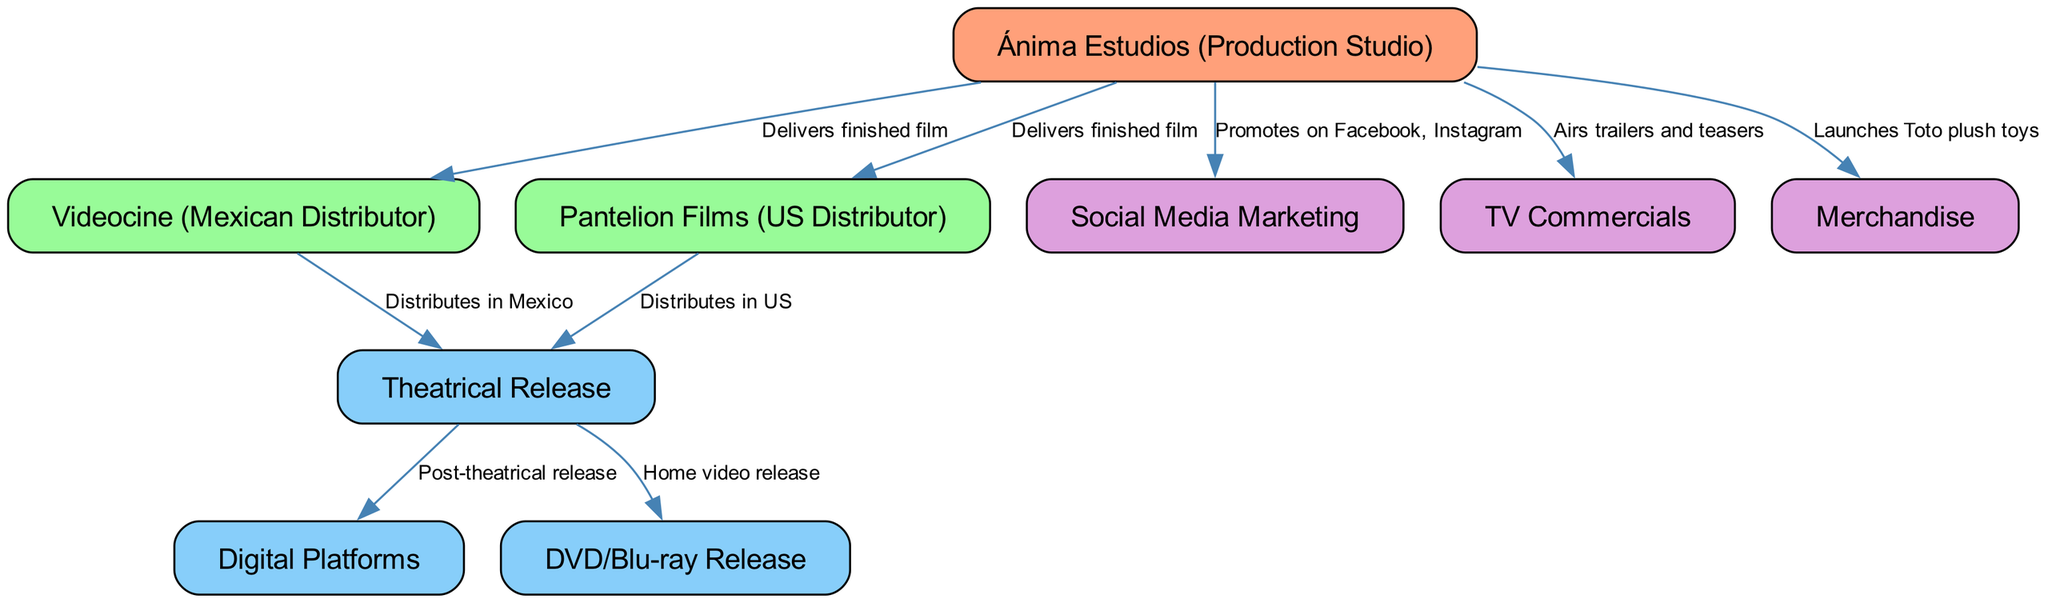What is the primary production studio for the "Huevos" series? The diagram shows that "Ánima Estudios" is the production studio responsible for creating the films, as it is the origin node in the diagram.
Answer: Ánima Estudios Which distributor handles the release in Mexico? According to the arrows connecting the nodes, "Videocine" is explicitly indicated as the distributor for the theatrical release in Mexico.
Answer: Videocine How many distinct release formats are shown in the diagram? By counting the nodes depicting release formats, we see three main formats: theatrical release, digital platforms, and DVD/Blu-ray release.
Answer: Three What type of marketing is primarily associated with social media? The diagram links "Social Media Marketing" directly to "Ánima Estudios", denoting that this studio promotes the films on platforms like Facebook and Instagram.
Answer: Social Media Marketing What is the first step in the distribution process for the "Huevos" films? The first edge connects "Ánima Estudios" to both "Videocine" and "Pantelion Films", indicating the delivery of the finished film to these distributors as the starting point.
Answer: Delivers finished film Which entities are involved in the US distribution? The diagram shows that "Pantelion Films" is the sole entity mentioned for US distribution as indicated by the edge leading to the "Theatrical Release".
Answer: Pantelion Films What marketing strategy involves airing trailers and teasers? The diagram points from "Ánima Estudios" to "TV Commercials", which indicates that this strategy involves airing promotional content for the films.
Answer: TV Commercials How does merchandise tie into the film's release? The edges show that "Ánima Estudios" launches merchandise, specifically "Toto plush toys", as part of the film's marketing efforts connected to the production.
Answer: Merchandise What happens after the theatrical release? The diagram indicates that after the theatrical release, the film moves to "Digital Platforms" and "DVD/Blu-ray Release", showcasing the next distribution steps.
Answer: Post-theatrical release 